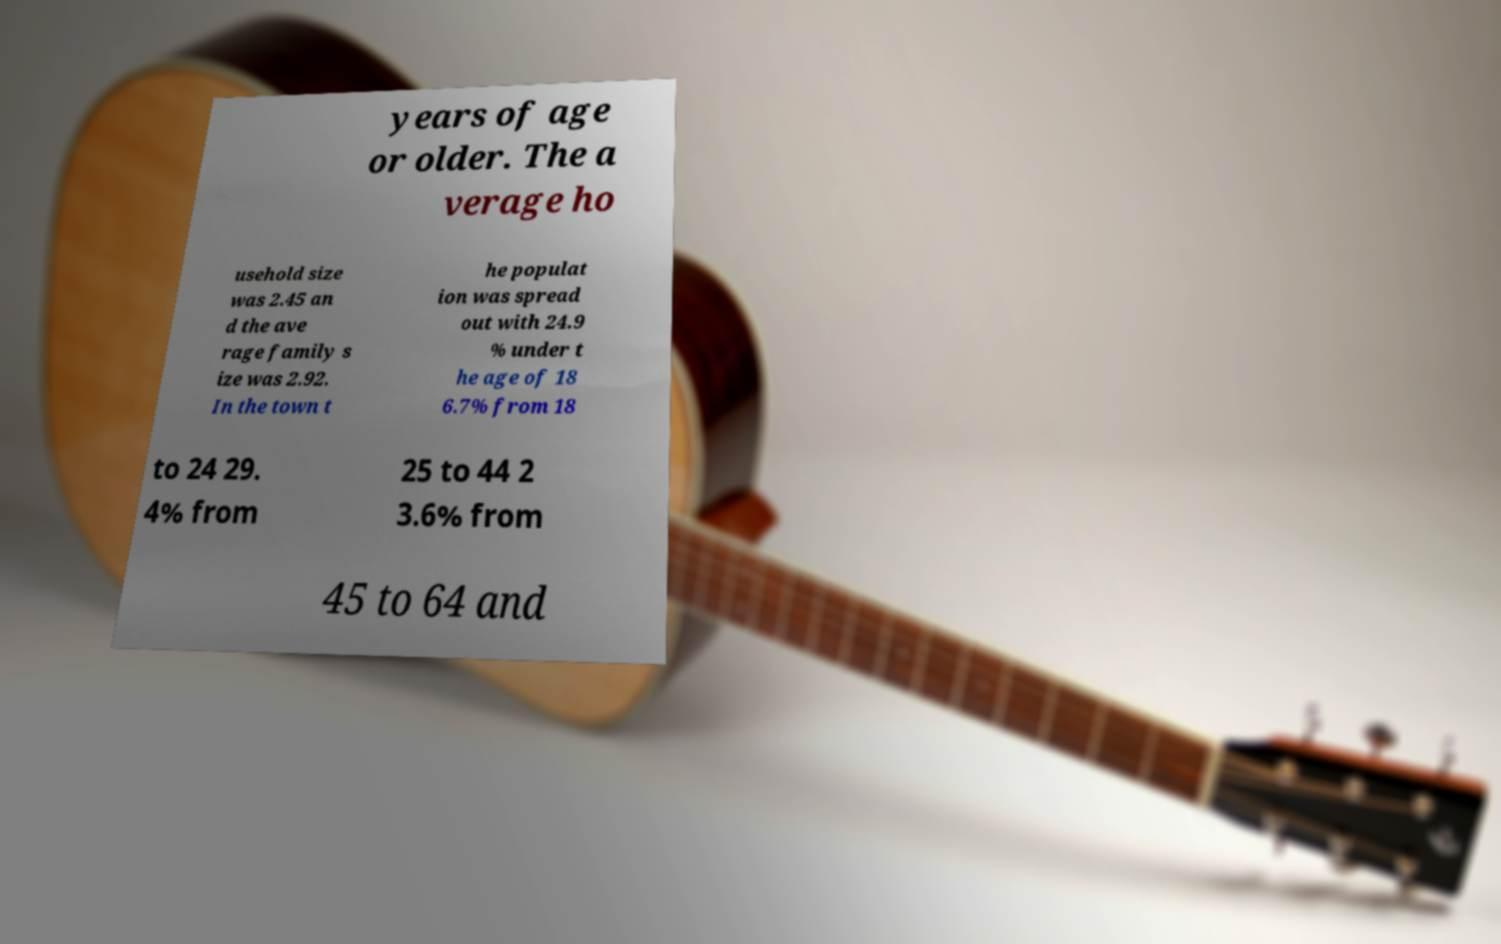Could you extract and type out the text from this image? years of age or older. The a verage ho usehold size was 2.45 an d the ave rage family s ize was 2.92. In the town t he populat ion was spread out with 24.9 % under t he age of 18 6.7% from 18 to 24 29. 4% from 25 to 44 2 3.6% from 45 to 64 and 